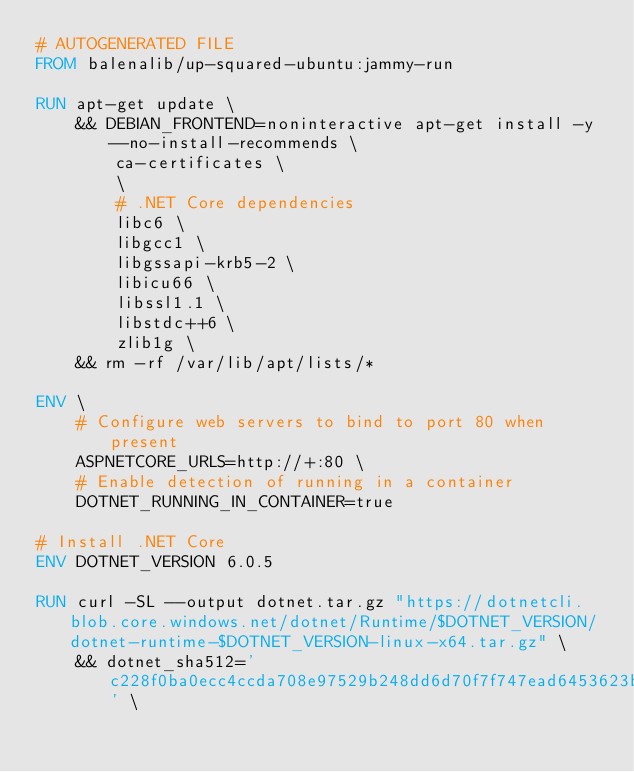Convert code to text. <code><loc_0><loc_0><loc_500><loc_500><_Dockerfile_># AUTOGENERATED FILE
FROM balenalib/up-squared-ubuntu:jammy-run

RUN apt-get update \
    && DEBIAN_FRONTEND=noninteractive apt-get install -y --no-install-recommends \
        ca-certificates \
        \
        # .NET Core dependencies
        libc6 \
        libgcc1 \
        libgssapi-krb5-2 \
        libicu66 \
        libssl1.1 \
        libstdc++6 \
        zlib1g \
    && rm -rf /var/lib/apt/lists/*

ENV \
    # Configure web servers to bind to port 80 when present
    ASPNETCORE_URLS=http://+:80 \
    # Enable detection of running in a container
    DOTNET_RUNNING_IN_CONTAINER=true

# Install .NET Core
ENV DOTNET_VERSION 6.0.5

RUN curl -SL --output dotnet.tar.gz "https://dotnetcli.blob.core.windows.net/dotnet/Runtime/$DOTNET_VERSION/dotnet-runtime-$DOTNET_VERSION-linux-x64.tar.gz" \
    && dotnet_sha512='c228f0ba0ecc4ccda708e97529b248dd6d70f7f747ead6453623be77e8e1529b54db52f5df1b5e00b5b7f92b73389560832f80607fc07e50879d55ce905afcf7' \</code> 